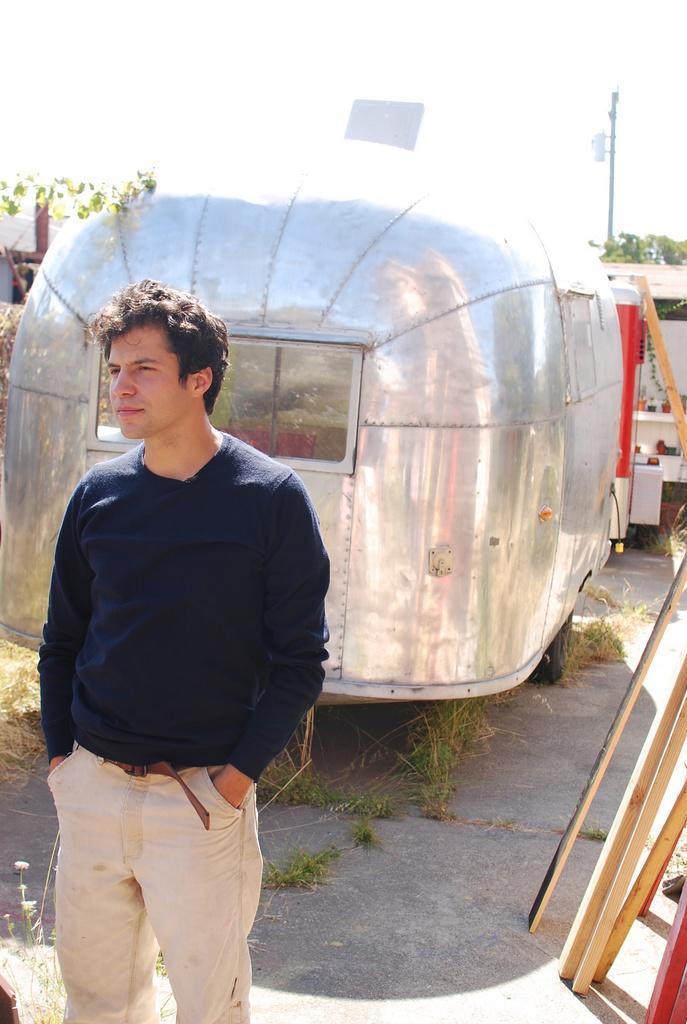Could you give a brief overview of what you see in this image? In the foreground of this image, there is a man standing. In the background, there is a vehicle, few wooden sticks on the right bottom. In the background, there is a pole, few trees and the sky. 